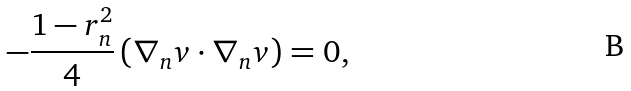Convert formula to latex. <formula><loc_0><loc_0><loc_500><loc_500>- \frac { 1 - r _ { n } ^ { 2 } } { 4 } \left ( \nabla _ { n } v \cdot \nabla _ { n } v \right ) = 0 ,</formula> 